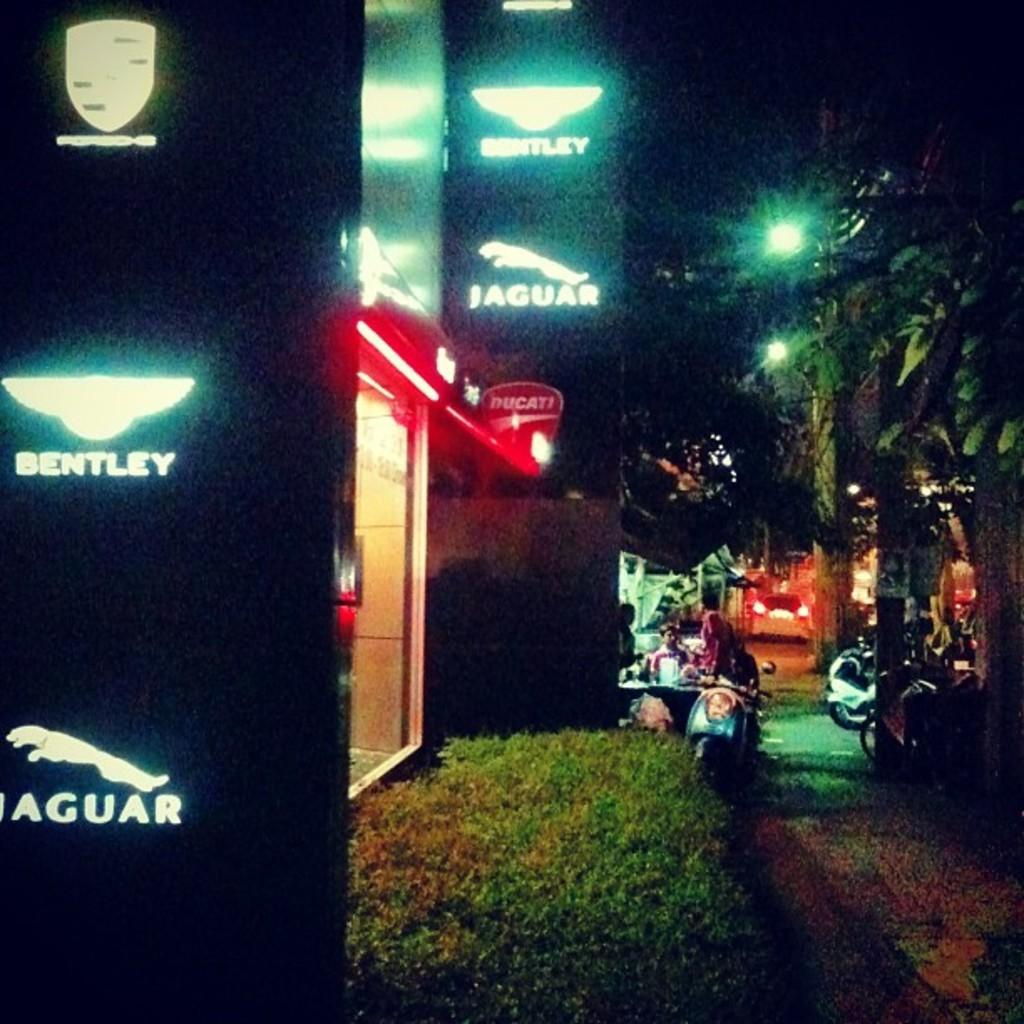What type of structure is present in the image? There is a building in the image. Are there any additional features near the building? Yes, there are lights and boards near the building. Can you describe the people visible in the image? There are people visible in the image, but their specific actions or characteristics are not mentioned in the provided facts. What type of toy can be seen in the throat of the person in the image? There is no toy or person mentioned in the provided facts, so it is not possible to answer that question. 